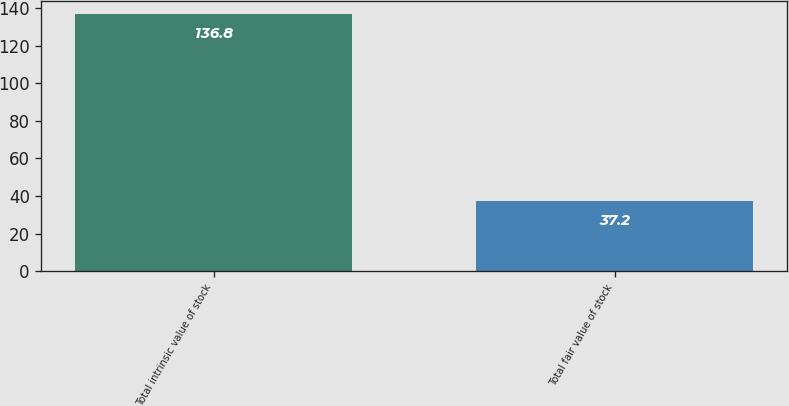Convert chart. <chart><loc_0><loc_0><loc_500><loc_500><bar_chart><fcel>Total intrinsic value of stock<fcel>Total fair value of stock<nl><fcel>136.8<fcel>37.2<nl></chart> 